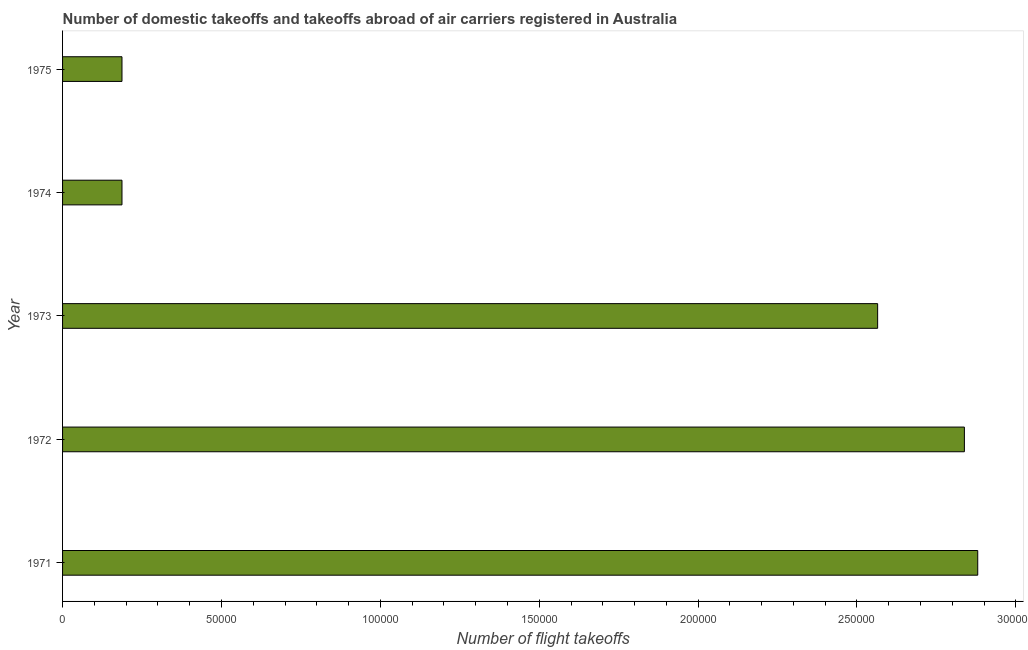Does the graph contain any zero values?
Offer a very short reply. No. Does the graph contain grids?
Your answer should be compact. No. What is the title of the graph?
Provide a short and direct response. Number of domestic takeoffs and takeoffs abroad of air carriers registered in Australia. What is the label or title of the X-axis?
Provide a succinct answer. Number of flight takeoffs. What is the label or title of the Y-axis?
Your answer should be compact. Year. What is the number of flight takeoffs in 1974?
Your answer should be compact. 1.87e+04. Across all years, what is the maximum number of flight takeoffs?
Offer a very short reply. 2.88e+05. Across all years, what is the minimum number of flight takeoffs?
Your answer should be very brief. 1.87e+04. In which year was the number of flight takeoffs minimum?
Make the answer very short. 1974. What is the sum of the number of flight takeoffs?
Your answer should be compact. 8.66e+05. What is the difference between the number of flight takeoffs in 1971 and 1975?
Your answer should be very brief. 2.69e+05. What is the average number of flight takeoffs per year?
Provide a short and direct response. 1.73e+05. What is the median number of flight takeoffs?
Provide a succinct answer. 2.56e+05. Do a majority of the years between 1973 and 1972 (inclusive) have number of flight takeoffs greater than 260000 ?
Offer a terse response. No. What is the ratio of the number of flight takeoffs in 1971 to that in 1973?
Ensure brevity in your answer.  1.12. What is the difference between the highest and the second highest number of flight takeoffs?
Offer a very short reply. 4200. What is the difference between the highest and the lowest number of flight takeoffs?
Provide a succinct answer. 2.69e+05. In how many years, is the number of flight takeoffs greater than the average number of flight takeoffs taken over all years?
Your answer should be compact. 3. Are all the bars in the graph horizontal?
Ensure brevity in your answer.  Yes. Are the values on the major ticks of X-axis written in scientific E-notation?
Provide a succinct answer. No. What is the Number of flight takeoffs in 1971?
Your answer should be compact. 2.88e+05. What is the Number of flight takeoffs in 1972?
Offer a terse response. 2.84e+05. What is the Number of flight takeoffs of 1973?
Provide a short and direct response. 2.56e+05. What is the Number of flight takeoffs of 1974?
Keep it short and to the point. 1.87e+04. What is the Number of flight takeoffs of 1975?
Ensure brevity in your answer.  1.87e+04. What is the difference between the Number of flight takeoffs in 1971 and 1972?
Your response must be concise. 4200. What is the difference between the Number of flight takeoffs in 1971 and 1973?
Give a very brief answer. 3.15e+04. What is the difference between the Number of flight takeoffs in 1971 and 1974?
Provide a succinct answer. 2.69e+05. What is the difference between the Number of flight takeoffs in 1971 and 1975?
Your answer should be very brief. 2.69e+05. What is the difference between the Number of flight takeoffs in 1972 and 1973?
Offer a terse response. 2.73e+04. What is the difference between the Number of flight takeoffs in 1972 and 1974?
Provide a short and direct response. 2.65e+05. What is the difference between the Number of flight takeoffs in 1972 and 1975?
Your answer should be very brief. 2.65e+05. What is the difference between the Number of flight takeoffs in 1973 and 1974?
Provide a succinct answer. 2.38e+05. What is the difference between the Number of flight takeoffs in 1973 and 1975?
Make the answer very short. 2.38e+05. What is the ratio of the Number of flight takeoffs in 1971 to that in 1973?
Give a very brief answer. 1.12. What is the ratio of the Number of flight takeoffs in 1971 to that in 1974?
Your response must be concise. 15.4. What is the ratio of the Number of flight takeoffs in 1971 to that in 1975?
Ensure brevity in your answer.  15.4. What is the ratio of the Number of flight takeoffs in 1972 to that in 1973?
Ensure brevity in your answer.  1.11. What is the ratio of the Number of flight takeoffs in 1972 to that in 1974?
Your answer should be very brief. 15.18. What is the ratio of the Number of flight takeoffs in 1972 to that in 1975?
Your response must be concise. 15.18. What is the ratio of the Number of flight takeoffs in 1973 to that in 1974?
Make the answer very short. 13.72. What is the ratio of the Number of flight takeoffs in 1973 to that in 1975?
Keep it short and to the point. 13.72. 